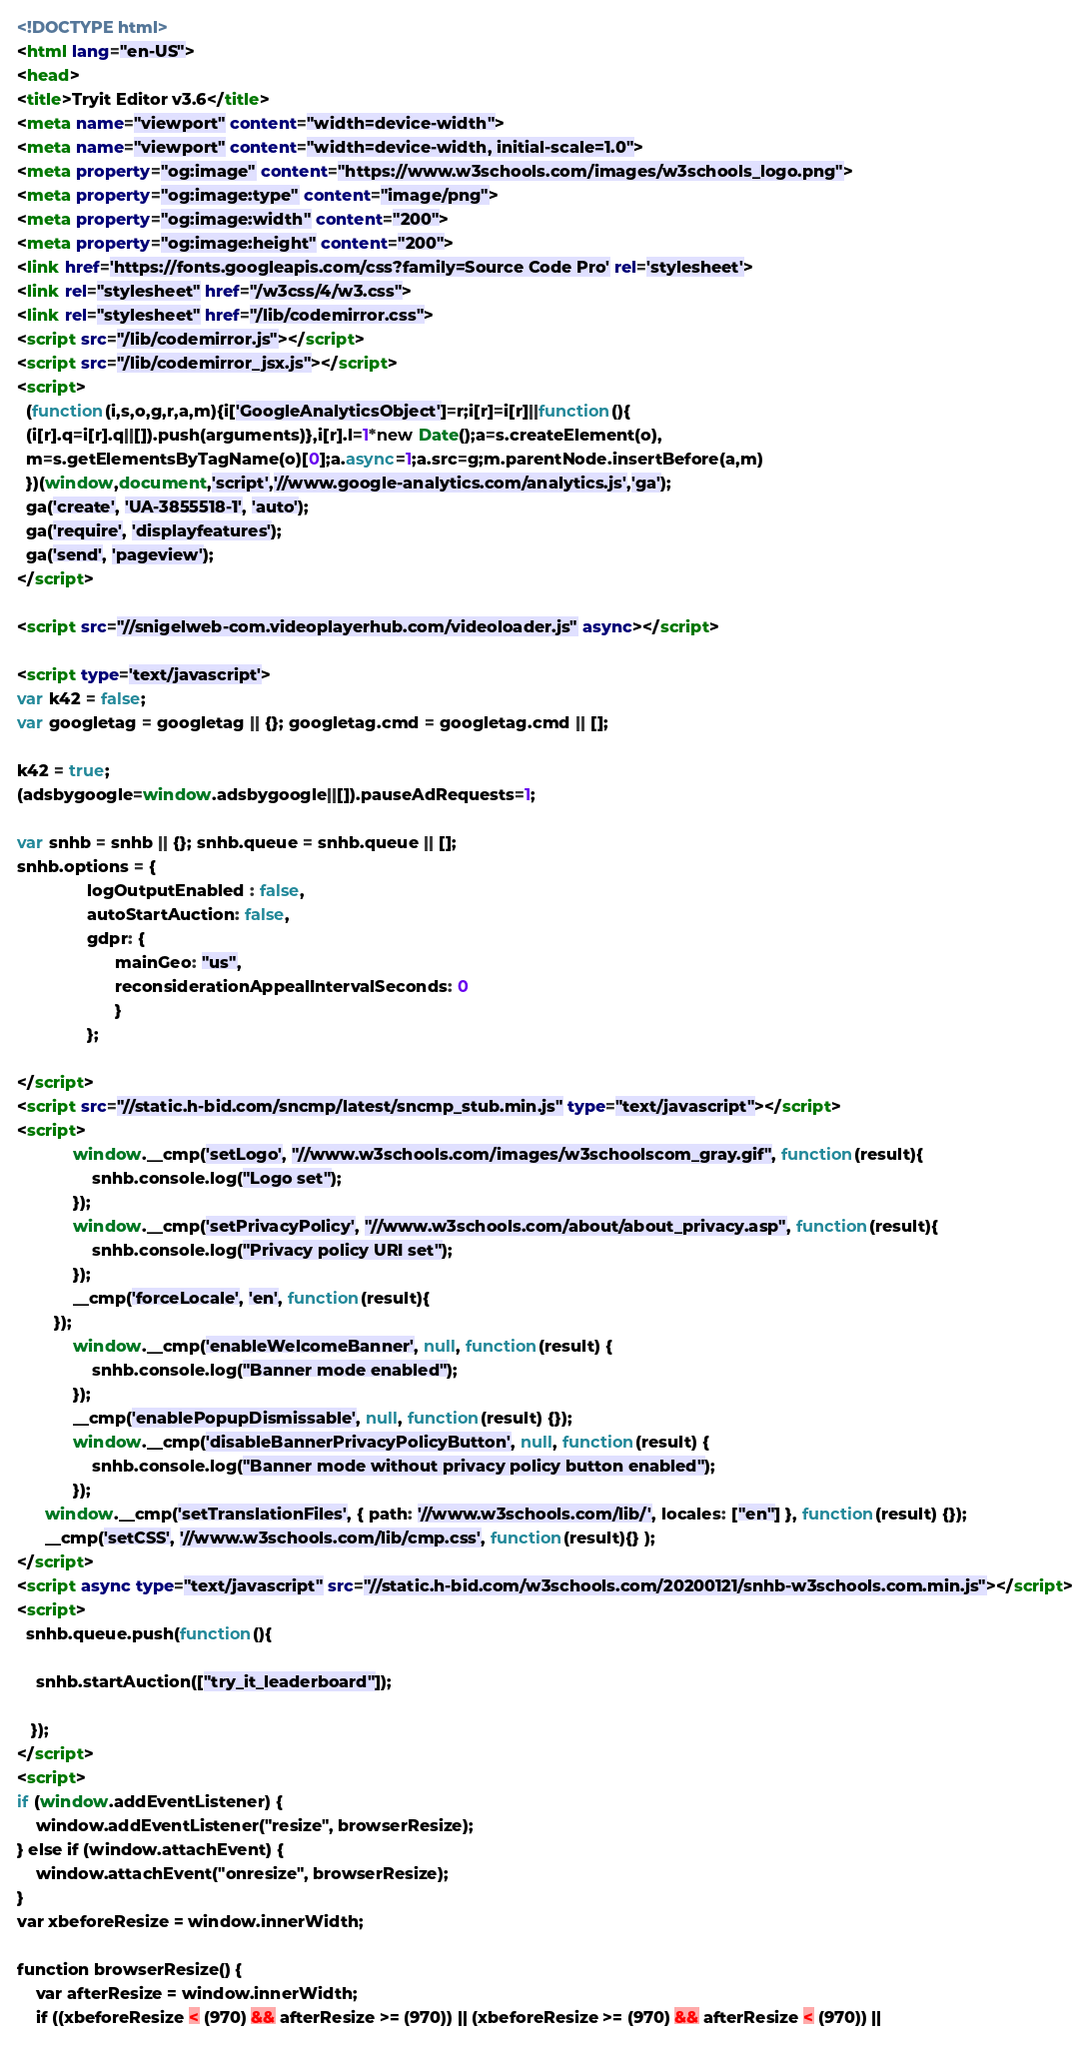<code> <loc_0><loc_0><loc_500><loc_500><_HTML_>
<!DOCTYPE html>
<html lang="en-US">
<head>
<title>Tryit Editor v3.6</title>
<meta name="viewport" content="width=device-width">
<meta name="viewport" content="width=device-width, initial-scale=1.0">
<meta property="og:image" content="https://www.w3schools.com/images/w3schools_logo.png">
<meta property="og:image:type" content="image/png">
<meta property="og:image:width" content="200">
<meta property="og:image:height" content="200">
<link href='https://fonts.googleapis.com/css?family=Source Code Pro' rel='stylesheet'>
<link rel="stylesheet" href="/w3css/4/w3.css">
<link rel="stylesheet" href="/lib/codemirror.css">
<script src="/lib/codemirror.js"></script>
<script src="/lib/codemirror_jsx.js"></script>
<script>
  (function(i,s,o,g,r,a,m){i['GoogleAnalyticsObject']=r;i[r]=i[r]||function(){
  (i[r].q=i[r].q||[]).push(arguments)},i[r].l=1*new Date();a=s.createElement(o),
  m=s.getElementsByTagName(o)[0];a.async=1;a.src=g;m.parentNode.insertBefore(a,m)
  })(window,document,'script','//www.google-analytics.com/analytics.js','ga');
  ga('create', 'UA-3855518-1', 'auto');
  ga('require', 'displayfeatures');
  ga('send', 'pageview');
</script>

<script src="//snigelweb-com.videoplayerhub.com/videoloader.js" async></script>

<script type='text/javascript'>
var k42 = false;
var googletag = googletag || {}; googletag.cmd = googletag.cmd || [];

k42 = true;
(adsbygoogle=window.adsbygoogle||[]).pauseAdRequests=1;

var snhb = snhb || {}; snhb.queue = snhb.queue || [];
snhb.options = {
               logOutputEnabled : false,
               autoStartAuction: false,
               gdpr: {
                     mainGeo: "us",
                     reconsiderationAppealIntervalSeconds: 0
                     }
               };

</script>
<script src="//static.h-bid.com/sncmp/latest/sncmp_stub.min.js" type="text/javascript"></script>
<script>
			window.__cmp('setLogo', "//www.w3schools.com/images/w3schoolscom_gray.gif", function(result){
	       		snhb.console.log("Logo set");
	    	});
			window.__cmp('setPrivacyPolicy', "//www.w3schools.com/about/about_privacy.asp", function(result){
	       		snhb.console.log("Privacy policy URI set");
	    	});
			__cmp('forceLocale', 'en', function(result){
	    });
			window.__cmp('enableWelcomeBanner', null, function(result) {
	       		snhb.console.log("Banner mode enabled");
			});
			__cmp('enablePopupDismissable', null, function(result) {});
			window.__cmp('disableBannerPrivacyPolicyButton', null, function(result) {
	       		snhb.console.log("Banner mode without privacy policy button enabled");
			});
      window.__cmp('setTranslationFiles', { path: '//www.w3schools.com/lib/', locales: ["en"] }, function(result) {});
      __cmp('setCSS', '//www.w3schools.com/lib/cmp.css', function(result){} );
</script>
<script async type="text/javascript" src="//static.h-bid.com/w3schools.com/20200121/snhb-w3schools.com.min.js"></script>
<script>
  snhb.queue.push(function(){

    snhb.startAuction(["try_it_leaderboard"]);

   });
</script>
<script>
if (window.addEventListener) {              
    window.addEventListener("resize", browserResize);
} else if (window.attachEvent) {                 
    window.attachEvent("onresize", browserResize);
}
var xbeforeResize = window.innerWidth;

function browserResize() {
    var afterResize = window.innerWidth;
    if ((xbeforeResize < (970) && afterResize >= (970)) || (xbeforeResize >= (970) && afterResize < (970)) ||</code> 